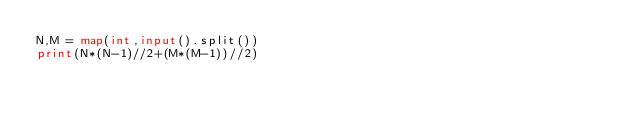Convert code to text. <code><loc_0><loc_0><loc_500><loc_500><_Python_>N,M = map(int,input().split())
print(N*(N-1)//2+(M*(M-1))//2)</code> 